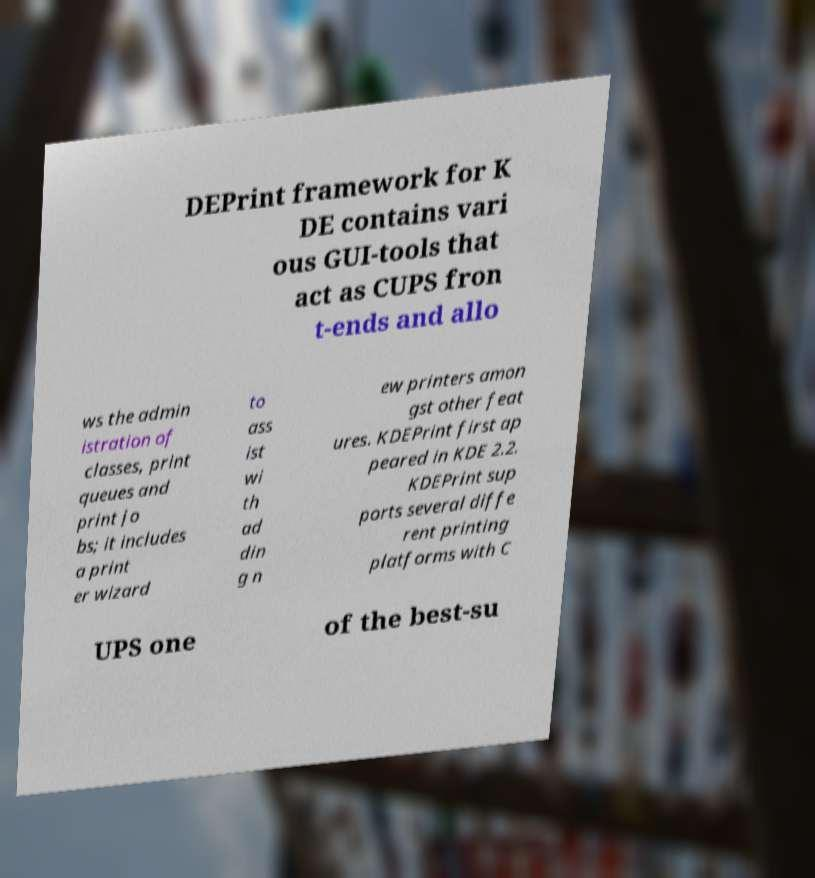There's text embedded in this image that I need extracted. Can you transcribe it verbatim? DEPrint framework for K DE contains vari ous GUI-tools that act as CUPS fron t-ends and allo ws the admin istration of classes, print queues and print jo bs; it includes a print er wizard to ass ist wi th ad din g n ew printers amon gst other feat ures. KDEPrint first ap peared in KDE 2.2. KDEPrint sup ports several diffe rent printing platforms with C UPS one of the best-su 